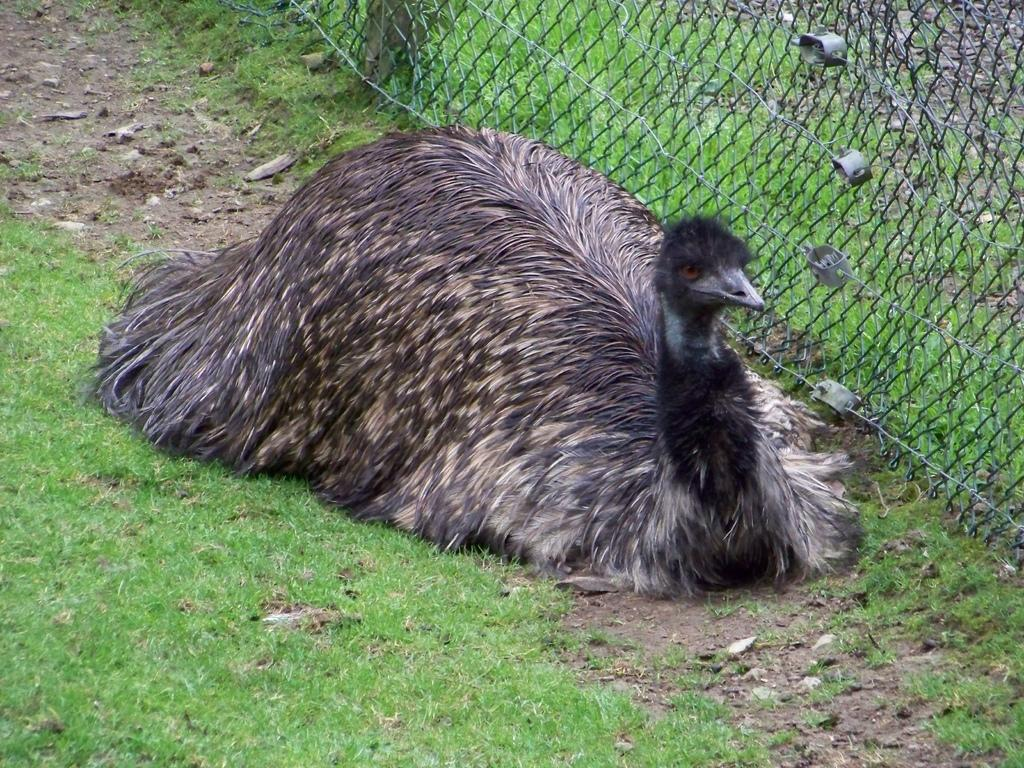What type of animal is in the image? There is an Emu bird in the image. Where is the Emu bird located? The Emu bird is sitting on the grass. What is the fence made of in the image? The fence is made of metal and is closed. What type of jail can be seen in the image? There is no jail present in the image; it features an Emu bird sitting on the grass and a closed metal fence. 